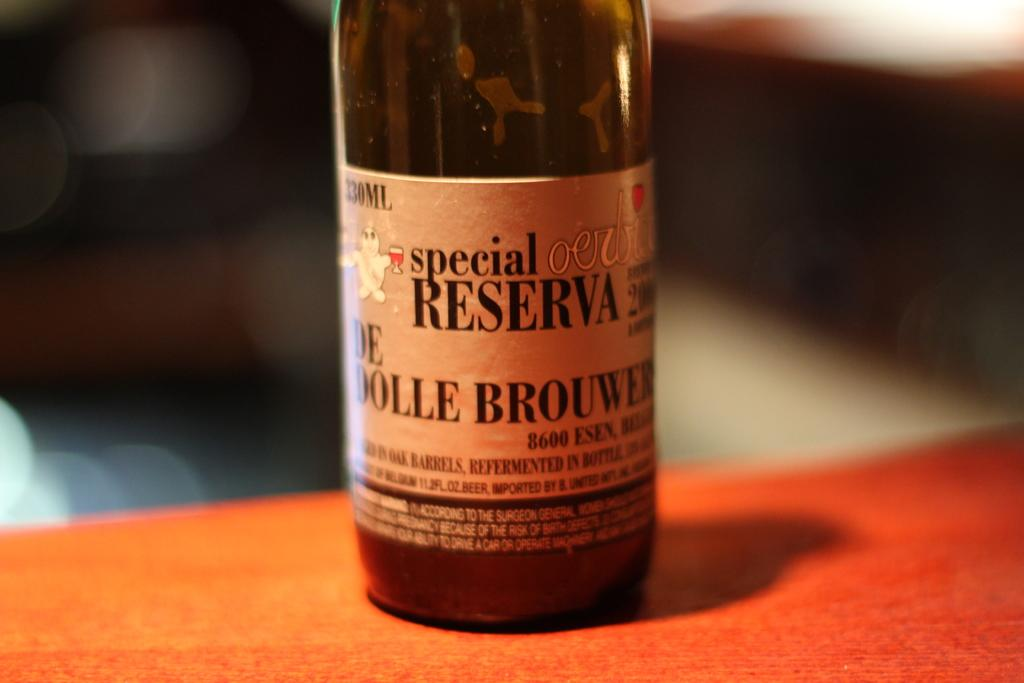<image>
Render a clear and concise summary of the photo. A bottle of De Dolle Brouwers beer sitting on a table 